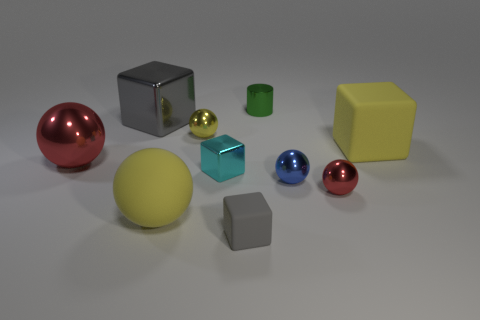There is another ball that is the same size as the rubber ball; what color is it?
Your answer should be very brief. Red. There is a gray block that is in front of the large red object; what is its size?
Provide a succinct answer. Small. There is a big matte thing to the right of the cyan object; are there any yellow blocks that are in front of it?
Give a very brief answer. No. Do the cube that is behind the big matte block and the small yellow thing have the same material?
Ensure brevity in your answer.  Yes. What number of big yellow objects are on the right side of the tiny gray rubber object and left of the tiny cyan cube?
Provide a succinct answer. 0. How many other large yellow cubes are made of the same material as the big yellow block?
Offer a very short reply. 0. There is a small block that is made of the same material as the small red thing; what color is it?
Offer a terse response. Cyan. Is the number of small brown metallic things less than the number of shiny blocks?
Offer a terse response. Yes. What is the material of the yellow sphere that is in front of the red object right of the big rubber object that is left of the blue metal sphere?
Provide a short and direct response. Rubber. What is the material of the small cyan block?
Provide a short and direct response. Metal. 